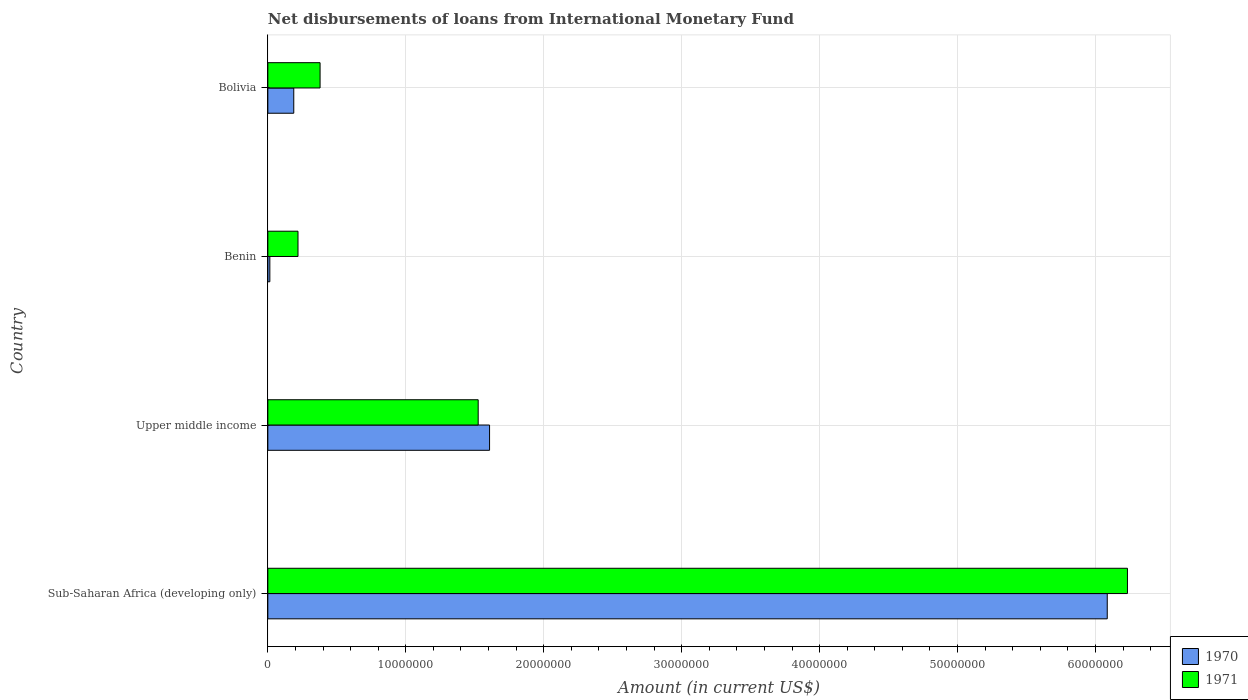How many different coloured bars are there?
Give a very brief answer. 2. How many groups of bars are there?
Keep it short and to the point. 4. How many bars are there on the 4th tick from the top?
Your response must be concise. 2. How many bars are there on the 3rd tick from the bottom?
Your answer should be very brief. 2. What is the label of the 2nd group of bars from the top?
Ensure brevity in your answer.  Benin. In how many cases, is the number of bars for a given country not equal to the number of legend labels?
Give a very brief answer. 0. What is the amount of loans disbursed in 1971 in Sub-Saharan Africa (developing only)?
Your answer should be compact. 6.23e+07. Across all countries, what is the maximum amount of loans disbursed in 1970?
Offer a very short reply. 6.09e+07. Across all countries, what is the minimum amount of loans disbursed in 1971?
Offer a terse response. 2.19e+06. In which country was the amount of loans disbursed in 1970 maximum?
Give a very brief answer. Sub-Saharan Africa (developing only). In which country was the amount of loans disbursed in 1970 minimum?
Give a very brief answer. Benin. What is the total amount of loans disbursed in 1970 in the graph?
Keep it short and to the point. 7.90e+07. What is the difference between the amount of loans disbursed in 1971 in Benin and that in Sub-Saharan Africa (developing only)?
Your answer should be very brief. -6.01e+07. What is the difference between the amount of loans disbursed in 1971 in Benin and the amount of loans disbursed in 1970 in Sub-Saharan Africa (developing only)?
Give a very brief answer. -5.87e+07. What is the average amount of loans disbursed in 1971 per country?
Make the answer very short. 2.09e+07. What is the difference between the amount of loans disbursed in 1971 and amount of loans disbursed in 1970 in Bolivia?
Keep it short and to the point. 1.91e+06. In how many countries, is the amount of loans disbursed in 1971 greater than 46000000 US$?
Your answer should be very brief. 1. What is the ratio of the amount of loans disbursed in 1970 in Benin to that in Upper middle income?
Your answer should be compact. 0.01. What is the difference between the highest and the second highest amount of loans disbursed in 1970?
Offer a very short reply. 4.48e+07. What is the difference between the highest and the lowest amount of loans disbursed in 1970?
Your response must be concise. 6.07e+07. In how many countries, is the amount of loans disbursed in 1970 greater than the average amount of loans disbursed in 1970 taken over all countries?
Give a very brief answer. 1. Is the sum of the amount of loans disbursed in 1971 in Bolivia and Sub-Saharan Africa (developing only) greater than the maximum amount of loans disbursed in 1970 across all countries?
Provide a succinct answer. Yes. What does the 1st bar from the top in Sub-Saharan Africa (developing only) represents?
Ensure brevity in your answer.  1971. What does the 2nd bar from the bottom in Bolivia represents?
Ensure brevity in your answer.  1971. How many bars are there?
Provide a succinct answer. 8. How many countries are there in the graph?
Your response must be concise. 4. What is the difference between two consecutive major ticks on the X-axis?
Provide a short and direct response. 1.00e+07. Are the values on the major ticks of X-axis written in scientific E-notation?
Offer a terse response. No. Does the graph contain any zero values?
Ensure brevity in your answer.  No. Where does the legend appear in the graph?
Provide a short and direct response. Bottom right. How are the legend labels stacked?
Your response must be concise. Vertical. What is the title of the graph?
Make the answer very short. Net disbursements of loans from International Monetary Fund. Does "1970" appear as one of the legend labels in the graph?
Provide a short and direct response. Yes. What is the label or title of the X-axis?
Your answer should be very brief. Amount (in current US$). What is the label or title of the Y-axis?
Your response must be concise. Country. What is the Amount (in current US$) in 1970 in Sub-Saharan Africa (developing only)?
Offer a terse response. 6.09e+07. What is the Amount (in current US$) of 1971 in Sub-Saharan Africa (developing only)?
Your answer should be very brief. 6.23e+07. What is the Amount (in current US$) of 1970 in Upper middle income?
Ensure brevity in your answer.  1.61e+07. What is the Amount (in current US$) in 1971 in Upper middle income?
Offer a terse response. 1.52e+07. What is the Amount (in current US$) in 1970 in Benin?
Provide a short and direct response. 1.45e+05. What is the Amount (in current US$) of 1971 in Benin?
Your response must be concise. 2.19e+06. What is the Amount (in current US$) of 1970 in Bolivia?
Ensure brevity in your answer.  1.88e+06. What is the Amount (in current US$) in 1971 in Bolivia?
Your answer should be compact. 3.79e+06. Across all countries, what is the maximum Amount (in current US$) in 1970?
Give a very brief answer. 6.09e+07. Across all countries, what is the maximum Amount (in current US$) of 1971?
Offer a terse response. 6.23e+07. Across all countries, what is the minimum Amount (in current US$) in 1970?
Provide a succinct answer. 1.45e+05. Across all countries, what is the minimum Amount (in current US$) of 1971?
Ensure brevity in your answer.  2.19e+06. What is the total Amount (in current US$) in 1970 in the graph?
Ensure brevity in your answer.  7.90e+07. What is the total Amount (in current US$) of 1971 in the graph?
Make the answer very short. 8.35e+07. What is the difference between the Amount (in current US$) in 1970 in Sub-Saharan Africa (developing only) and that in Upper middle income?
Provide a succinct answer. 4.48e+07. What is the difference between the Amount (in current US$) in 1971 in Sub-Saharan Africa (developing only) and that in Upper middle income?
Make the answer very short. 4.71e+07. What is the difference between the Amount (in current US$) of 1970 in Sub-Saharan Africa (developing only) and that in Benin?
Provide a short and direct response. 6.07e+07. What is the difference between the Amount (in current US$) in 1971 in Sub-Saharan Africa (developing only) and that in Benin?
Your answer should be compact. 6.01e+07. What is the difference between the Amount (in current US$) of 1970 in Sub-Saharan Africa (developing only) and that in Bolivia?
Ensure brevity in your answer.  5.90e+07. What is the difference between the Amount (in current US$) of 1971 in Sub-Saharan Africa (developing only) and that in Bolivia?
Ensure brevity in your answer.  5.85e+07. What is the difference between the Amount (in current US$) of 1970 in Upper middle income and that in Benin?
Provide a short and direct response. 1.59e+07. What is the difference between the Amount (in current US$) in 1971 in Upper middle income and that in Benin?
Keep it short and to the point. 1.31e+07. What is the difference between the Amount (in current US$) of 1970 in Upper middle income and that in Bolivia?
Offer a very short reply. 1.42e+07. What is the difference between the Amount (in current US$) in 1971 in Upper middle income and that in Bolivia?
Give a very brief answer. 1.15e+07. What is the difference between the Amount (in current US$) of 1970 in Benin and that in Bolivia?
Offer a terse response. -1.73e+06. What is the difference between the Amount (in current US$) of 1971 in Benin and that in Bolivia?
Offer a terse response. -1.60e+06. What is the difference between the Amount (in current US$) of 1970 in Sub-Saharan Africa (developing only) and the Amount (in current US$) of 1971 in Upper middle income?
Offer a terse response. 4.56e+07. What is the difference between the Amount (in current US$) in 1970 in Sub-Saharan Africa (developing only) and the Amount (in current US$) in 1971 in Benin?
Offer a terse response. 5.87e+07. What is the difference between the Amount (in current US$) of 1970 in Sub-Saharan Africa (developing only) and the Amount (in current US$) of 1971 in Bolivia?
Provide a short and direct response. 5.71e+07. What is the difference between the Amount (in current US$) of 1970 in Upper middle income and the Amount (in current US$) of 1971 in Benin?
Offer a very short reply. 1.39e+07. What is the difference between the Amount (in current US$) of 1970 in Upper middle income and the Amount (in current US$) of 1971 in Bolivia?
Your answer should be very brief. 1.23e+07. What is the difference between the Amount (in current US$) in 1970 in Benin and the Amount (in current US$) in 1971 in Bolivia?
Your answer should be compact. -3.64e+06. What is the average Amount (in current US$) in 1970 per country?
Provide a succinct answer. 1.97e+07. What is the average Amount (in current US$) in 1971 per country?
Provide a succinct answer. 2.09e+07. What is the difference between the Amount (in current US$) of 1970 and Amount (in current US$) of 1971 in Sub-Saharan Africa (developing only)?
Provide a succinct answer. -1.46e+06. What is the difference between the Amount (in current US$) in 1970 and Amount (in current US$) in 1971 in Upper middle income?
Your response must be concise. 8.24e+05. What is the difference between the Amount (in current US$) of 1970 and Amount (in current US$) of 1971 in Benin?
Your answer should be compact. -2.04e+06. What is the difference between the Amount (in current US$) of 1970 and Amount (in current US$) of 1971 in Bolivia?
Your answer should be very brief. -1.91e+06. What is the ratio of the Amount (in current US$) in 1970 in Sub-Saharan Africa (developing only) to that in Upper middle income?
Ensure brevity in your answer.  3.79. What is the ratio of the Amount (in current US$) in 1971 in Sub-Saharan Africa (developing only) to that in Upper middle income?
Your answer should be very brief. 4.09. What is the ratio of the Amount (in current US$) of 1970 in Sub-Saharan Africa (developing only) to that in Benin?
Offer a very short reply. 419.7. What is the ratio of the Amount (in current US$) of 1971 in Sub-Saharan Africa (developing only) to that in Benin?
Your answer should be compact. 28.51. What is the ratio of the Amount (in current US$) in 1970 in Sub-Saharan Africa (developing only) to that in Bolivia?
Give a very brief answer. 32.39. What is the ratio of the Amount (in current US$) in 1971 in Sub-Saharan Africa (developing only) to that in Bolivia?
Keep it short and to the point. 16.46. What is the ratio of the Amount (in current US$) of 1970 in Upper middle income to that in Benin?
Your answer should be very brief. 110.86. What is the ratio of the Amount (in current US$) of 1971 in Upper middle income to that in Benin?
Your answer should be compact. 6.98. What is the ratio of the Amount (in current US$) in 1970 in Upper middle income to that in Bolivia?
Offer a terse response. 8.55. What is the ratio of the Amount (in current US$) of 1971 in Upper middle income to that in Bolivia?
Your answer should be very brief. 4.03. What is the ratio of the Amount (in current US$) of 1970 in Benin to that in Bolivia?
Your answer should be compact. 0.08. What is the ratio of the Amount (in current US$) of 1971 in Benin to that in Bolivia?
Your answer should be very brief. 0.58. What is the difference between the highest and the second highest Amount (in current US$) in 1970?
Your answer should be very brief. 4.48e+07. What is the difference between the highest and the second highest Amount (in current US$) in 1971?
Provide a succinct answer. 4.71e+07. What is the difference between the highest and the lowest Amount (in current US$) of 1970?
Your answer should be very brief. 6.07e+07. What is the difference between the highest and the lowest Amount (in current US$) of 1971?
Your response must be concise. 6.01e+07. 